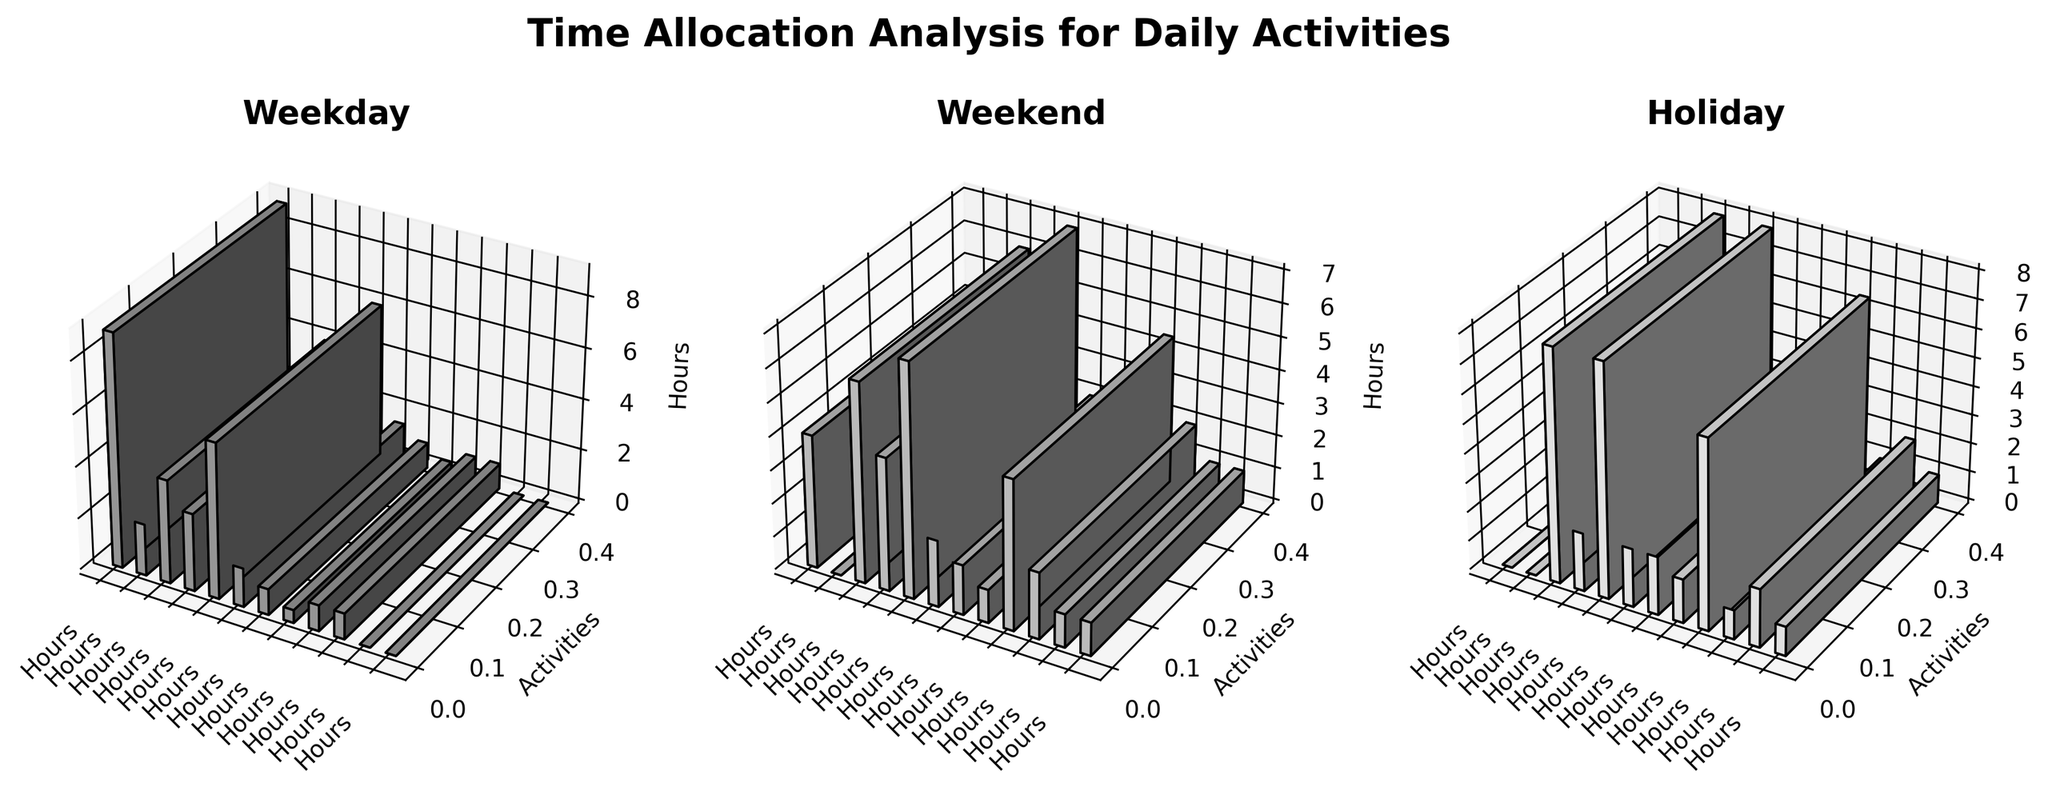Which activity takes the most time on weekdays? By looking at the bar heights for the 'Weekday' subplot, the tallest bar corresponds to the activity 'Work'.
Answer: Work How many hours are spent on childcare during weekends? Refer to the 'Weekend' subplot and find the bar corresponding to 'Childcare'. The height of the bar indicates the hours, which is 6.
Answer: 6 Compare the time spent on sleep between weekdays and weekends. Locate the bars for 'Sleep' in both the 'Weekday' and 'Weekend' subplots. On the 'Weekday' subplot, the height is 6 hours, while on the 'Weekend' subplot, it's 7 hours.
Answer: 7 hours on weekends, 6 hours on weekdays What's the difference in the hours spent on leisure activities during holidays and weekends? Look at the 'Leisure' bars in both 'Holiday' and 'Weekend' subplots. For holidays it's 6.5 hours, and for weekends it's 4.5 hours. Subtracting these gives 2 hours.
Answer: 2 hours Which activity has the least amount of time allocated on weekends? In the 'Weekend' subplot, the shortest bar belongs to 'Commute' with 0 hours.
Answer: Commute What's the total amount of time spent on housework from weekdays to holidays? Sum up the hours allocated to 'Housework' on weekdays (3 hours), weekends (4 hours), and holidays (2 hours). The total is 3 + 4 + 2 = 9 hours.
Answer: 9 hours On holidays, do you spend more time on social activities or exercise? Compare the height of the bars corresponding to 'Social Activities' (2 hours) and 'Exercise' (1 hour) in the 'Holiday' subplot.
Answer: Social Activities Is meal preparation time higher during weekends compared to weekdays? Compare the heights of the 'Meal Preparation' bars in 'Weekend' (2 hours) and 'Weekday' (1.5 hours) subplots.
Answer: Yes What's the average time spent on eating throughout the week (all categories)? Find the heights of the 'Eating' bars in all subplots: Weekday (1 hour), Weekend (1.5 hours), and Holiday (2 hours). Calculate the average (1+1.5+2)/3 = 1.5 hours.
Answer: 1.5 hours Which day category has the most hours allocated for personal care? Check the 'Personal Care' bars in every subplot. Weekday has 0.5 hours, Weekend has 1 hour, Holiday has 1.5 hours. The highest is on holidays.
Answer: Holidays 